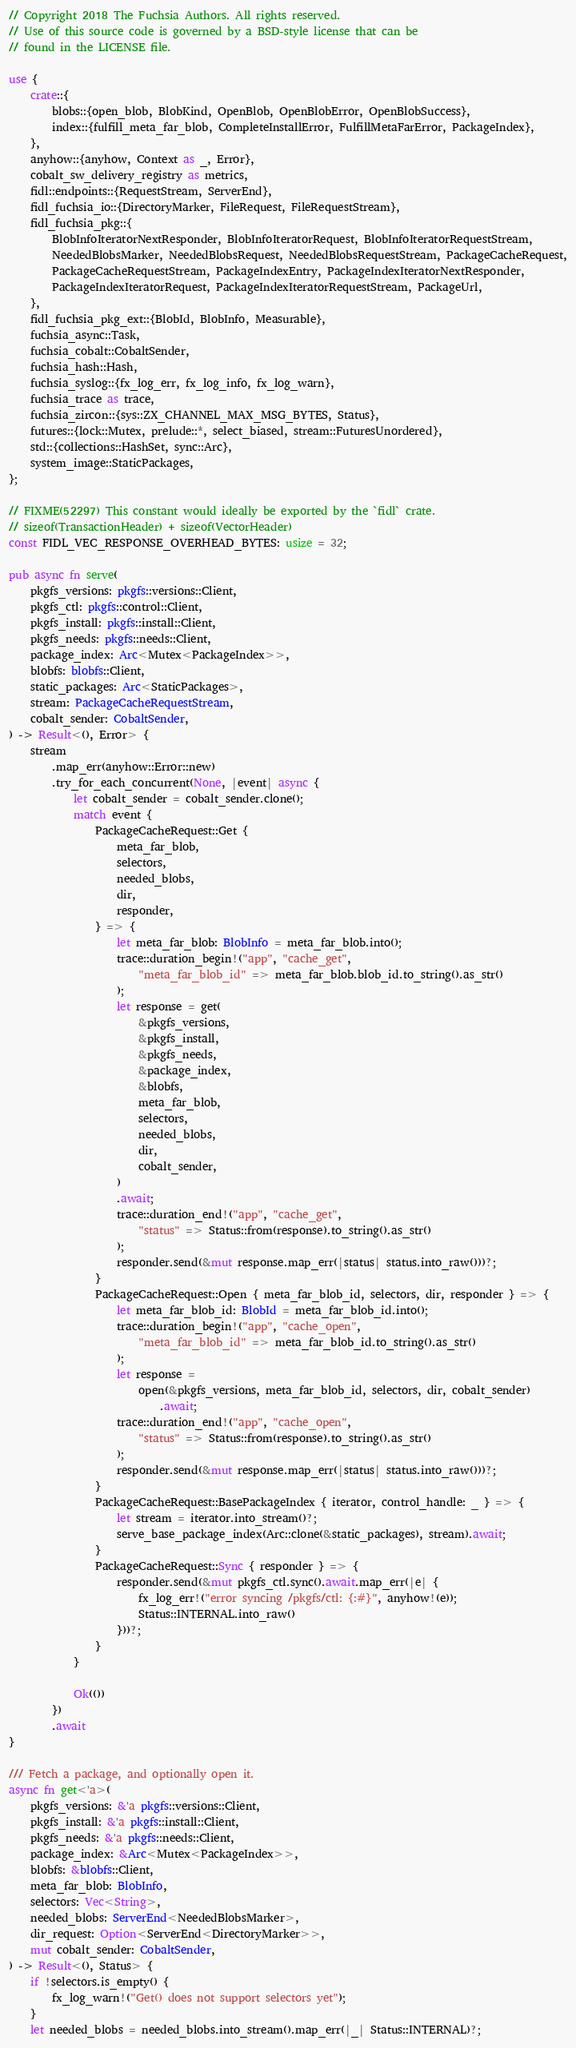<code> <loc_0><loc_0><loc_500><loc_500><_Rust_>// Copyright 2018 The Fuchsia Authors. All rights reserved.
// Use of this source code is governed by a BSD-style license that can be
// found in the LICENSE file.

use {
    crate::{
        blobs::{open_blob, BlobKind, OpenBlob, OpenBlobError, OpenBlobSuccess},
        index::{fulfill_meta_far_blob, CompleteInstallError, FulfillMetaFarError, PackageIndex},
    },
    anyhow::{anyhow, Context as _, Error},
    cobalt_sw_delivery_registry as metrics,
    fidl::endpoints::{RequestStream, ServerEnd},
    fidl_fuchsia_io::{DirectoryMarker, FileRequest, FileRequestStream},
    fidl_fuchsia_pkg::{
        BlobInfoIteratorNextResponder, BlobInfoIteratorRequest, BlobInfoIteratorRequestStream,
        NeededBlobsMarker, NeededBlobsRequest, NeededBlobsRequestStream, PackageCacheRequest,
        PackageCacheRequestStream, PackageIndexEntry, PackageIndexIteratorNextResponder,
        PackageIndexIteratorRequest, PackageIndexIteratorRequestStream, PackageUrl,
    },
    fidl_fuchsia_pkg_ext::{BlobId, BlobInfo, Measurable},
    fuchsia_async::Task,
    fuchsia_cobalt::CobaltSender,
    fuchsia_hash::Hash,
    fuchsia_syslog::{fx_log_err, fx_log_info, fx_log_warn},
    fuchsia_trace as trace,
    fuchsia_zircon::{sys::ZX_CHANNEL_MAX_MSG_BYTES, Status},
    futures::{lock::Mutex, prelude::*, select_biased, stream::FuturesUnordered},
    std::{collections::HashSet, sync::Arc},
    system_image::StaticPackages,
};

// FIXME(52297) This constant would ideally be exported by the `fidl` crate.
// sizeof(TransactionHeader) + sizeof(VectorHeader)
const FIDL_VEC_RESPONSE_OVERHEAD_BYTES: usize = 32;

pub async fn serve(
    pkgfs_versions: pkgfs::versions::Client,
    pkgfs_ctl: pkgfs::control::Client,
    pkgfs_install: pkgfs::install::Client,
    pkgfs_needs: pkgfs::needs::Client,
    package_index: Arc<Mutex<PackageIndex>>,
    blobfs: blobfs::Client,
    static_packages: Arc<StaticPackages>,
    stream: PackageCacheRequestStream,
    cobalt_sender: CobaltSender,
) -> Result<(), Error> {
    stream
        .map_err(anyhow::Error::new)
        .try_for_each_concurrent(None, |event| async {
            let cobalt_sender = cobalt_sender.clone();
            match event {
                PackageCacheRequest::Get {
                    meta_far_blob,
                    selectors,
                    needed_blobs,
                    dir,
                    responder,
                } => {
                    let meta_far_blob: BlobInfo = meta_far_blob.into();
                    trace::duration_begin!("app", "cache_get",
                        "meta_far_blob_id" => meta_far_blob.blob_id.to_string().as_str()
                    );
                    let response = get(
                        &pkgfs_versions,
                        &pkgfs_install,
                        &pkgfs_needs,
                        &package_index,
                        &blobfs,
                        meta_far_blob,
                        selectors,
                        needed_blobs,
                        dir,
                        cobalt_sender,
                    )
                    .await;
                    trace::duration_end!("app", "cache_get",
                        "status" => Status::from(response).to_string().as_str()
                    );
                    responder.send(&mut response.map_err(|status| status.into_raw()))?;
                }
                PackageCacheRequest::Open { meta_far_blob_id, selectors, dir, responder } => {
                    let meta_far_blob_id: BlobId = meta_far_blob_id.into();
                    trace::duration_begin!("app", "cache_open",
                        "meta_far_blob_id" => meta_far_blob_id.to_string().as_str()
                    );
                    let response =
                        open(&pkgfs_versions, meta_far_blob_id, selectors, dir, cobalt_sender)
                            .await;
                    trace::duration_end!("app", "cache_open",
                        "status" => Status::from(response).to_string().as_str()
                    );
                    responder.send(&mut response.map_err(|status| status.into_raw()))?;
                }
                PackageCacheRequest::BasePackageIndex { iterator, control_handle: _ } => {
                    let stream = iterator.into_stream()?;
                    serve_base_package_index(Arc::clone(&static_packages), stream).await;
                }
                PackageCacheRequest::Sync { responder } => {
                    responder.send(&mut pkgfs_ctl.sync().await.map_err(|e| {
                        fx_log_err!("error syncing /pkgfs/ctl: {:#}", anyhow!(e));
                        Status::INTERNAL.into_raw()
                    }))?;
                }
            }

            Ok(())
        })
        .await
}

/// Fetch a package, and optionally open it.
async fn get<'a>(
    pkgfs_versions: &'a pkgfs::versions::Client,
    pkgfs_install: &'a pkgfs::install::Client,
    pkgfs_needs: &'a pkgfs::needs::Client,
    package_index: &Arc<Mutex<PackageIndex>>,
    blobfs: &blobfs::Client,
    meta_far_blob: BlobInfo,
    selectors: Vec<String>,
    needed_blobs: ServerEnd<NeededBlobsMarker>,
    dir_request: Option<ServerEnd<DirectoryMarker>>,
    mut cobalt_sender: CobaltSender,
) -> Result<(), Status> {
    if !selectors.is_empty() {
        fx_log_warn!("Get() does not support selectors yet");
    }
    let needed_blobs = needed_blobs.into_stream().map_err(|_| Status::INTERNAL)?;
</code> 